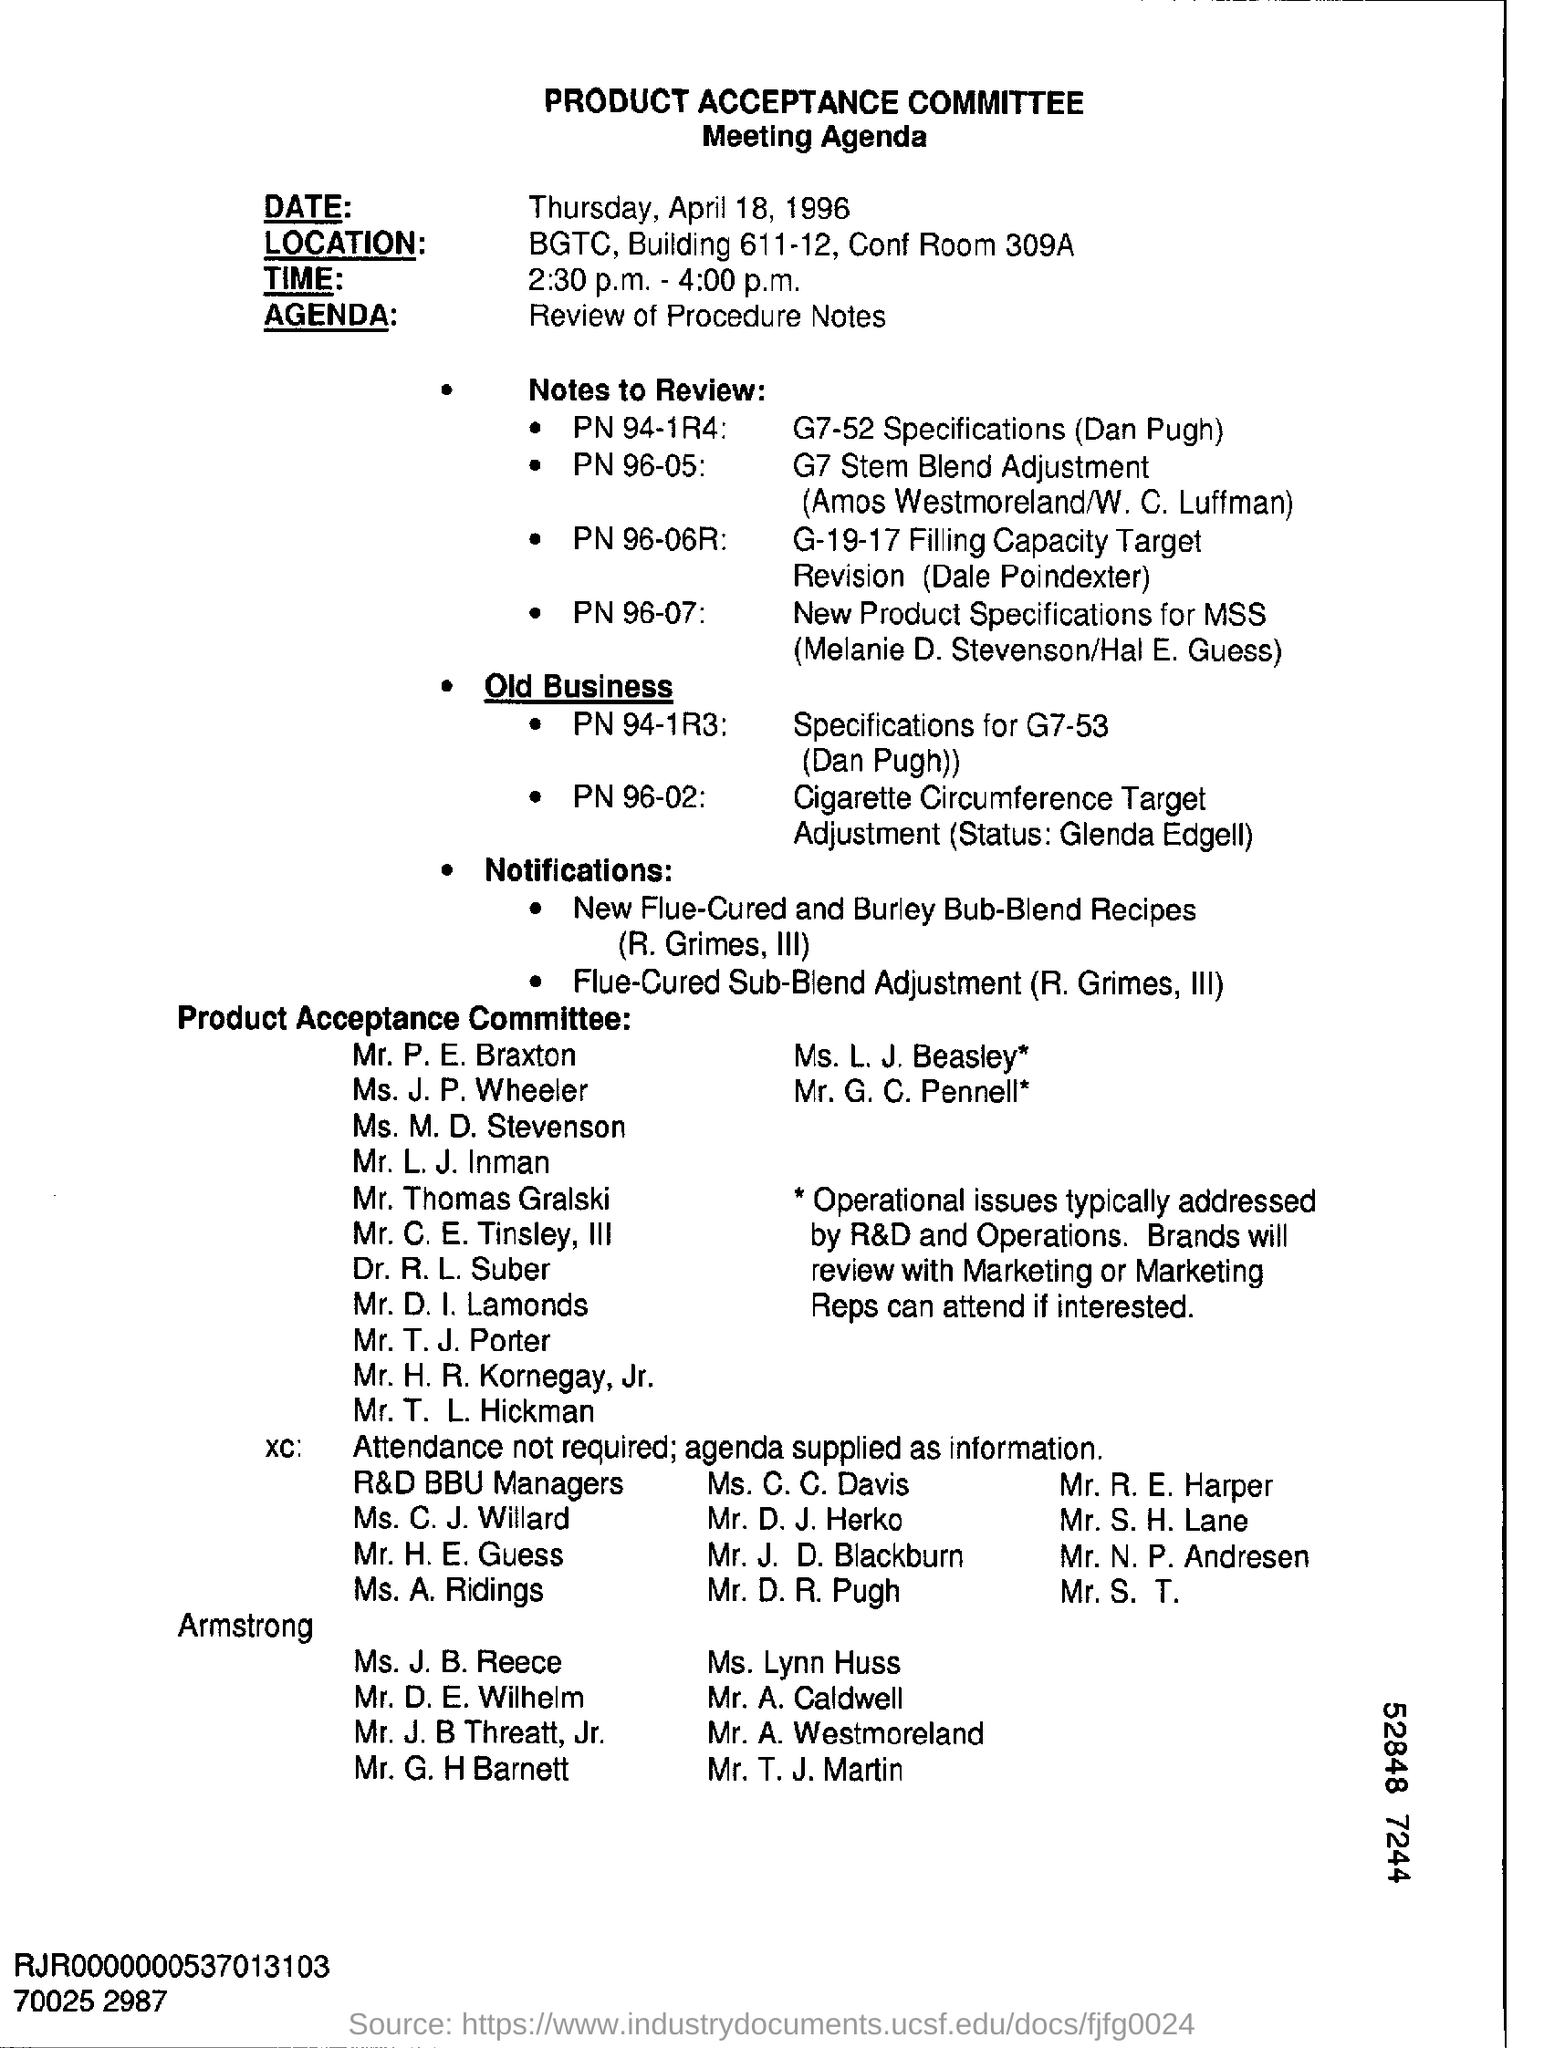Outline some significant characteristics in this image. The Product Acceptance Committee Meeting is scheduled to take place from 2:30 p.m. to 4:00 p.m. The Product Acceptance Committee Meeting is scheduled for Thursday, April 18, 1996. The Agenda Field contains the written content 'Review of Procedure Notes.' The Product Acceptance Committee is the name of the committee. 